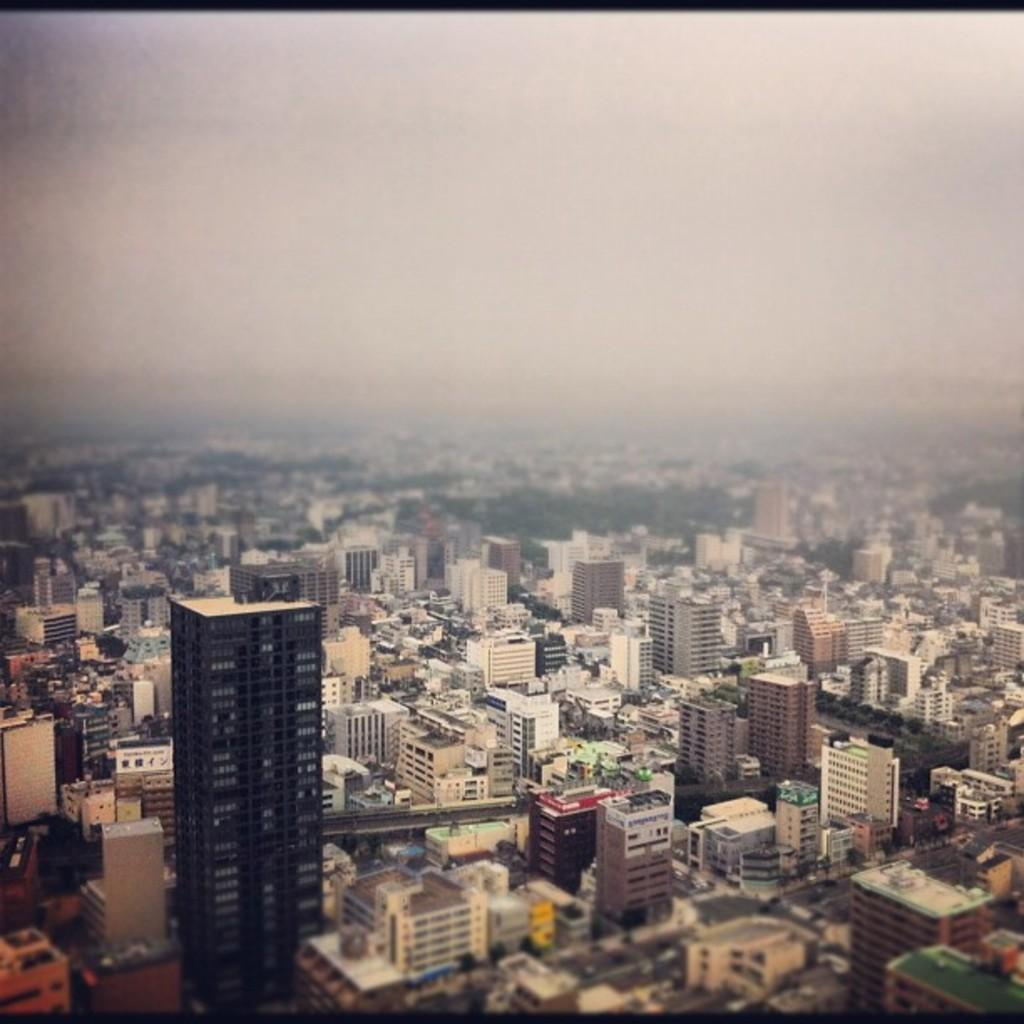What type of structures can be seen in the image? There are buildings in the image. What else is present in the image besides buildings? There is greenery and other objects in the image. Can you describe the natural elements in the image? The greenery in the image consists of plants or trees. What is visible in the background of the image? The sky is visible in the image. What type of cabbage is being served in the office in the image? There is no cabbage or office present in the image; it features buildings, greenery, and other objects. Can you tell me the name of the son who is playing with the cabbage in the image? There is no son or cabbage present in the image. 